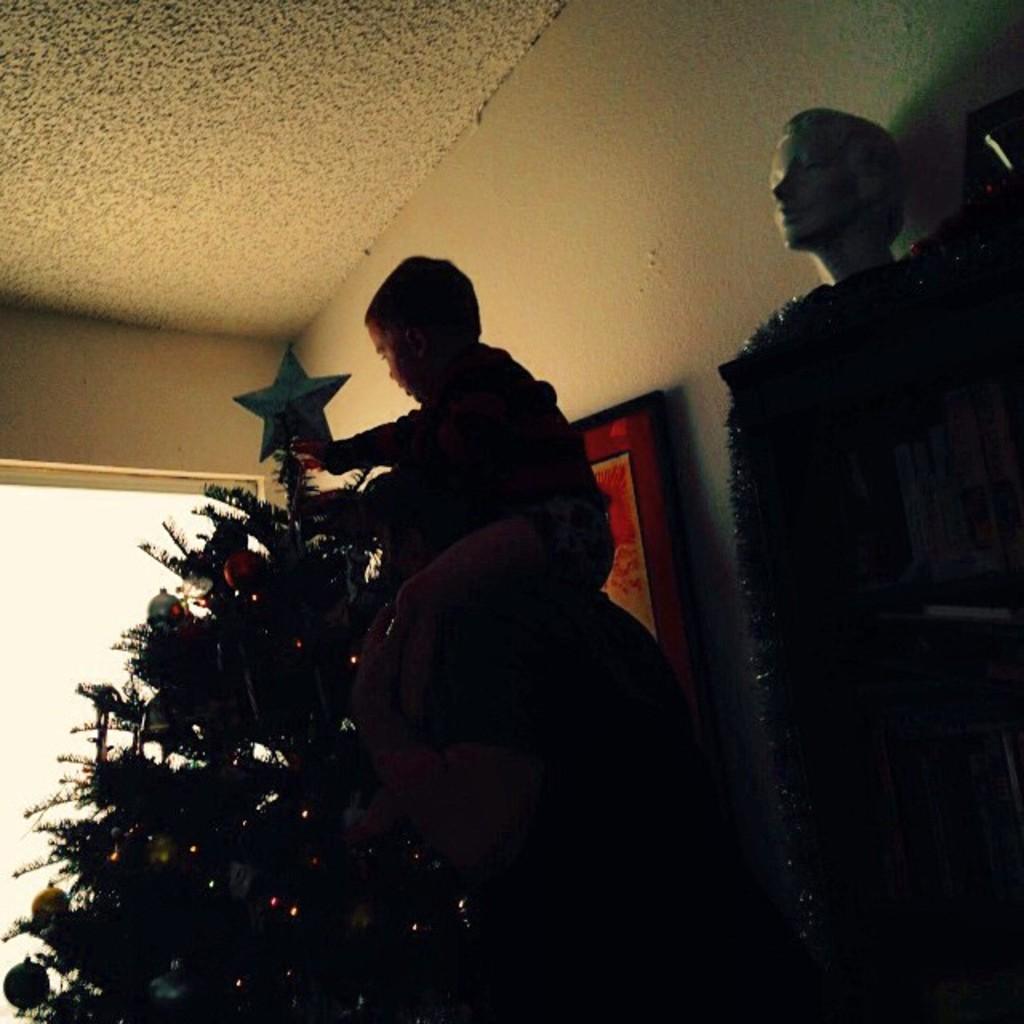Describe this image in one or two sentences. In this image there is a man in the middle who is lifting the kid by keeping him on his shoulders. In front of them there is a Christmas tree on which there is a star and some decorative items. On the right side there is a mannequin. In the background there is the wall on which there is the photo frame. 